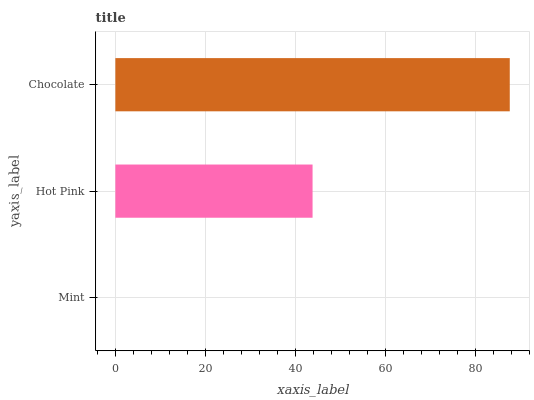Is Mint the minimum?
Answer yes or no. Yes. Is Chocolate the maximum?
Answer yes or no. Yes. Is Hot Pink the minimum?
Answer yes or no. No. Is Hot Pink the maximum?
Answer yes or no. No. Is Hot Pink greater than Mint?
Answer yes or no. Yes. Is Mint less than Hot Pink?
Answer yes or no. Yes. Is Mint greater than Hot Pink?
Answer yes or no. No. Is Hot Pink less than Mint?
Answer yes or no. No. Is Hot Pink the high median?
Answer yes or no. Yes. Is Hot Pink the low median?
Answer yes or no. Yes. Is Mint the high median?
Answer yes or no. No. Is Chocolate the low median?
Answer yes or no. No. 